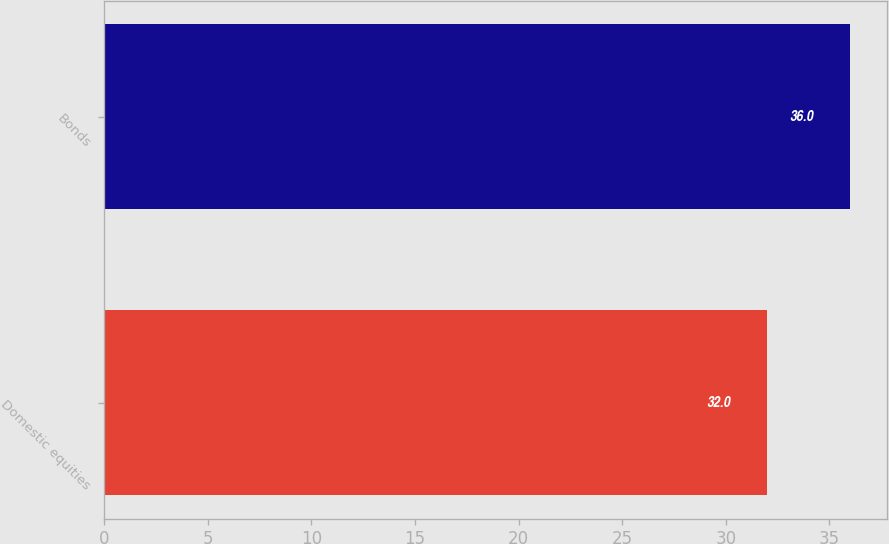<chart> <loc_0><loc_0><loc_500><loc_500><bar_chart><fcel>Domestic equities<fcel>Bonds<nl><fcel>32<fcel>36<nl></chart> 